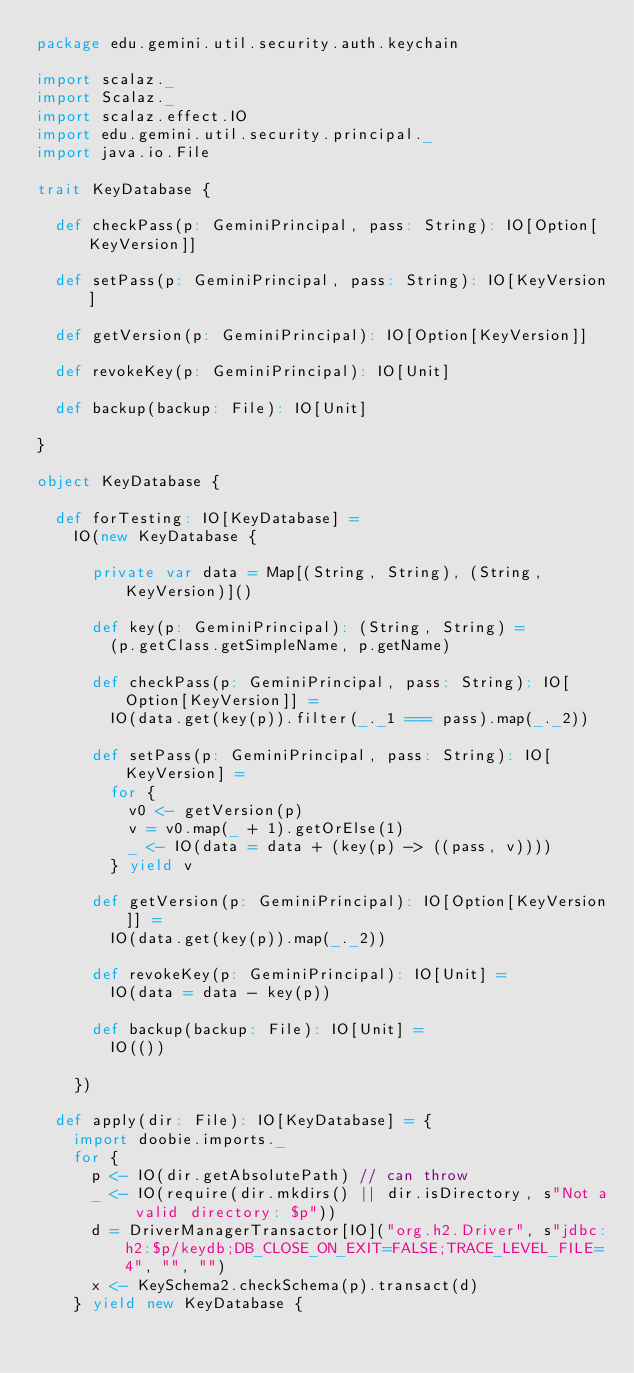<code> <loc_0><loc_0><loc_500><loc_500><_Scala_>package edu.gemini.util.security.auth.keychain

import scalaz._
import Scalaz._
import scalaz.effect.IO
import edu.gemini.util.security.principal._
import java.io.File

trait KeyDatabase {

  def checkPass(p: GeminiPrincipal, pass: String): IO[Option[KeyVersion]]

  def setPass(p: GeminiPrincipal, pass: String): IO[KeyVersion]

  def getVersion(p: GeminiPrincipal): IO[Option[KeyVersion]]

  def revokeKey(p: GeminiPrincipal): IO[Unit]

  def backup(backup: File): IO[Unit]

}

object KeyDatabase {

  def forTesting: IO[KeyDatabase] =
    IO(new KeyDatabase {

      private var data = Map[(String, String), (String, KeyVersion)]()

      def key(p: GeminiPrincipal): (String, String) =
        (p.getClass.getSimpleName, p.getName)

      def checkPass(p: GeminiPrincipal, pass: String): IO[Option[KeyVersion]] =
        IO(data.get(key(p)).filter(_._1 === pass).map(_._2))

      def setPass(p: GeminiPrincipal, pass: String): IO[KeyVersion] =
        for {
          v0 <- getVersion(p)
          v = v0.map(_ + 1).getOrElse(1)
          _ <- IO(data = data + (key(p) -> ((pass, v))))
        } yield v

      def getVersion(p: GeminiPrincipal): IO[Option[KeyVersion]] =
        IO(data.get(key(p)).map(_._2))

      def revokeKey(p: GeminiPrincipal): IO[Unit] =
        IO(data = data - key(p))

      def backup(backup: File): IO[Unit] =
        IO(())

    })

  def apply(dir: File): IO[KeyDatabase] = {
    import doobie.imports._
    for {
      p <- IO(dir.getAbsolutePath) // can throw
      _ <- IO(require(dir.mkdirs() || dir.isDirectory, s"Not a valid directory: $p"))
      d = DriverManagerTransactor[IO]("org.h2.Driver", s"jdbc:h2:$p/keydb;DB_CLOSE_ON_EXIT=FALSE;TRACE_LEVEL_FILE=4", "", "")
      x <- KeySchema2.checkSchema(p).transact(d)
    } yield new KeyDatabase {
</code> 